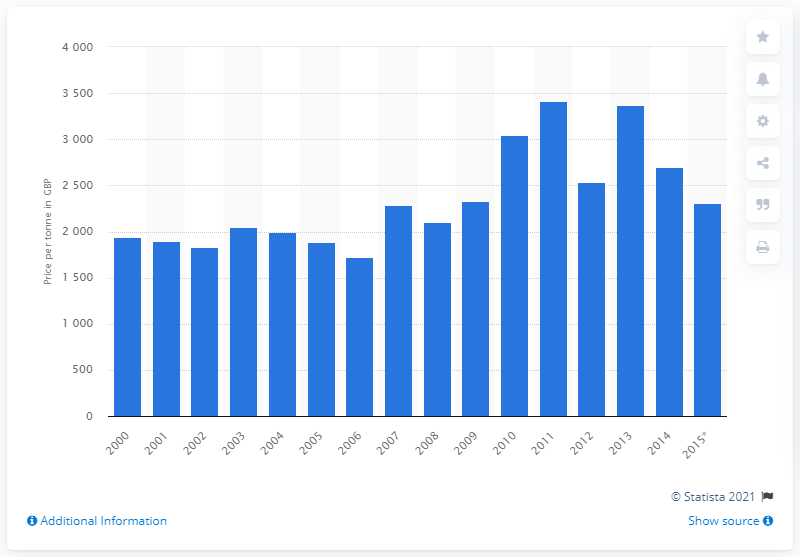Outline some significant characteristics in this image. In 2012, the average price per tonne of butter was 2531.25. 